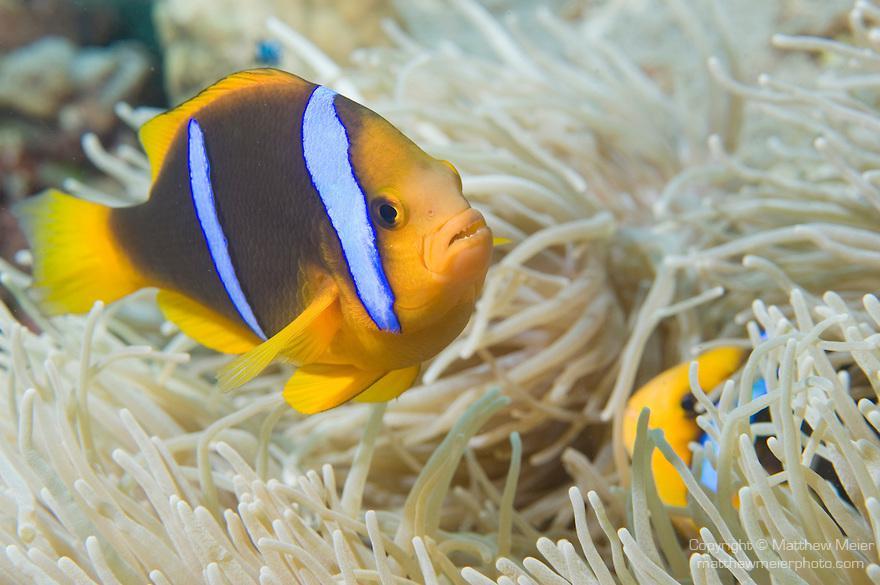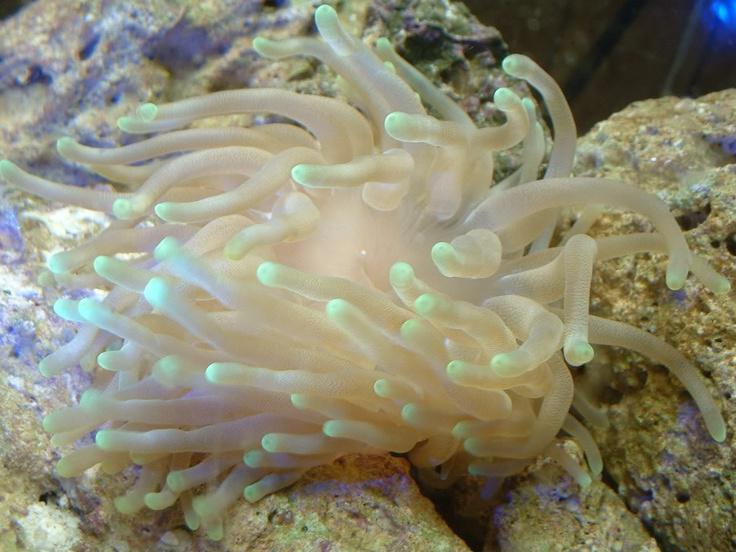The first image is the image on the left, the second image is the image on the right. Assess this claim about the two images: "The only living thing in one of the images is an anemone.". Correct or not? Answer yes or no. Yes. The first image is the image on the left, the second image is the image on the right. Evaluate the accuracy of this statement regarding the images: "At least one image shows a bright yellow anemone with tendrils that have a black dot on the end.". Is it true? Answer yes or no. No. 